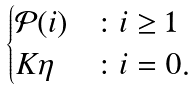Convert formula to latex. <formula><loc_0><loc_0><loc_500><loc_500>\begin{cases} { \mathcal { P } } ( i ) & \colon i \geq 1 \\ K \eta & \colon i = 0 . \\ \end{cases}</formula> 